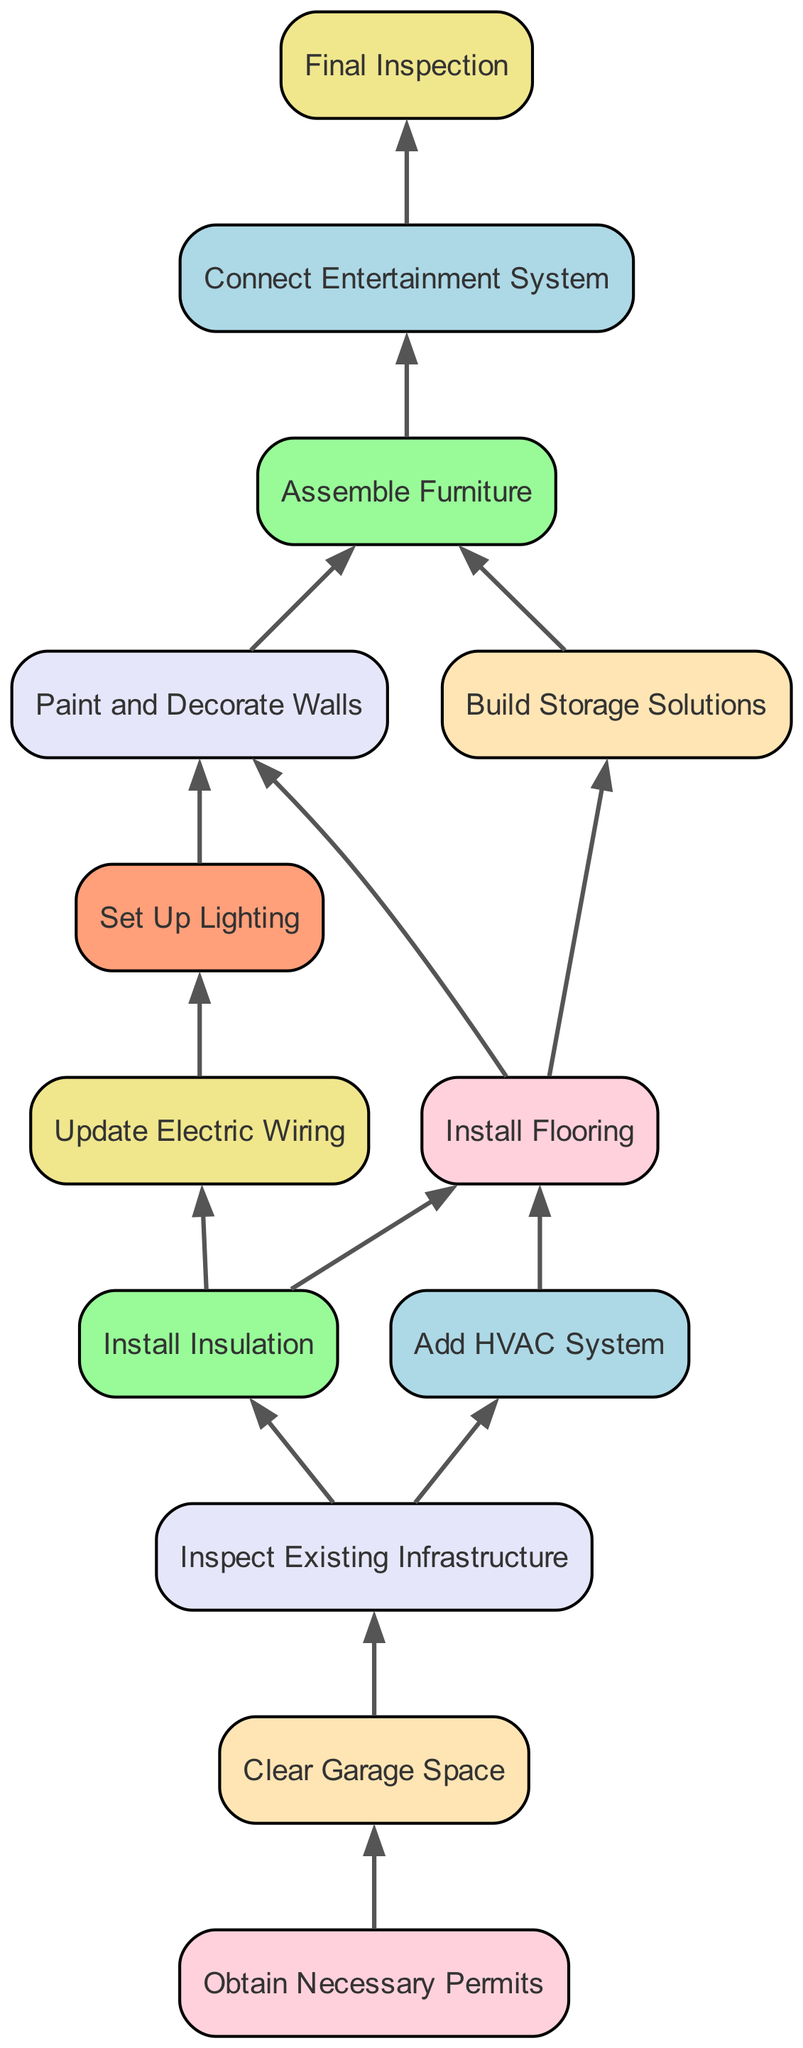What is the first task in the diagram? The first task listed with no dependencies is "Obtain Necessary Permits." Since it's at the bottom of the flowchart, it indicates that this task must be completed first before moving on to any others.
Answer: Obtain Necessary Permits How many tasks are in the diagram? By counting all the listed tasks, there are a total of 12 distinct tasks shown in the diagram.
Answer: 12 Which task directly depends on "Inspect Existing Infrastructure"? The tasks that directly depend on "Inspect Existing Infrastructure" are "Install Insulation" and "Add HVAC System." Since they are both connected to "Inspect Existing Infrastructure," they cannot start until that task is completed.
Answer: Install Insulation and Add HVAC System What is the final task in the sequence? The last task in the flowchart that must be completed is "Final Inspection." It follows "Connect Entertainment System," which must be finished first, making it the final step in the sequence.
Answer: Final Inspection How many tasks depend on "Install Insulation"? There are two tasks that depend on "Install Insulation": "Update Electric Wiring" and "Install Flooring." Both of these tasks cannot start until "Install Insulation" is completed.
Answer: 2 Which task must be completed immediately after "Assemble Furniture"? The task that follows "Assemble Furniture" in the sequence is "Connect Entertainment System." This means that once the furniture is assembled, the next step is to connect the entertainment system.
Answer: Connect Entertainment System What is the dependency relationship of "Paint and Decorate Walls"? The task "Paint and Decorate Walls" depends on two previous tasks: "Set Up Lighting" and "Install Flooring." Both of these must be completed before this task can begin.
Answer: Depends on Set Up Lighting and Install Flooring What color is assigned to the task "Clear Garage Space"? The assigned color for "Clear Garage Space" is a light pink shade, denoted by the color code #FFD1DC in the diagram. Each task has a unique corresponding node color.
Answer: Light pink Which task has the most dependencies? The task with the most dependencies is "Assemble Furniture," which relies on both "Paint and Decorate Walls" and "Build Storage Solutions." This indicates a complex flow where multiple tasks must be finished before starting this one.
Answer: Assemble Furniture 